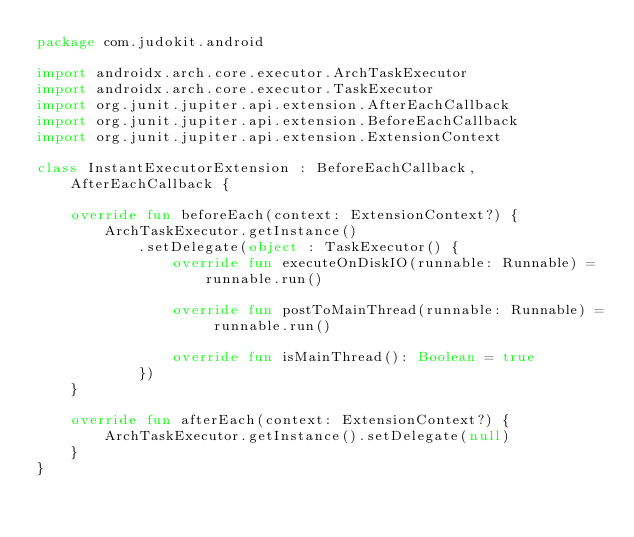<code> <loc_0><loc_0><loc_500><loc_500><_Kotlin_>package com.judokit.android

import androidx.arch.core.executor.ArchTaskExecutor
import androidx.arch.core.executor.TaskExecutor
import org.junit.jupiter.api.extension.AfterEachCallback
import org.junit.jupiter.api.extension.BeforeEachCallback
import org.junit.jupiter.api.extension.ExtensionContext

class InstantExecutorExtension : BeforeEachCallback, AfterEachCallback {

    override fun beforeEach(context: ExtensionContext?) {
        ArchTaskExecutor.getInstance()
            .setDelegate(object : TaskExecutor() {
                override fun executeOnDiskIO(runnable: Runnable) = runnable.run()

                override fun postToMainThread(runnable: Runnable) = runnable.run()

                override fun isMainThread(): Boolean = true
            })
    }

    override fun afterEach(context: ExtensionContext?) {
        ArchTaskExecutor.getInstance().setDelegate(null)
    }
}
</code> 